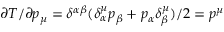<formula> <loc_0><loc_0><loc_500><loc_500>\partial T / \partial p _ { \mu } = \delta ^ { \alpha \beta } ( \delta _ { \alpha } ^ { \mu } p _ { \beta } + p _ { \alpha } \delta _ { \beta } ^ { \mu } ) / 2 = p ^ { \mu }</formula> 